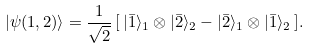Convert formula to latex. <formula><loc_0><loc_0><loc_500><loc_500>| \psi ( 1 , 2 ) \rangle = \frac { 1 } { \sqrt { 2 } } \, [ \, | \bar { 1 } \rangle _ { 1 } \otimes | \bar { 2 } \rangle _ { 2 } - | \bar { 2 } \rangle _ { 1 } \otimes | \bar { 1 } \rangle _ { 2 } \, ] .</formula> 